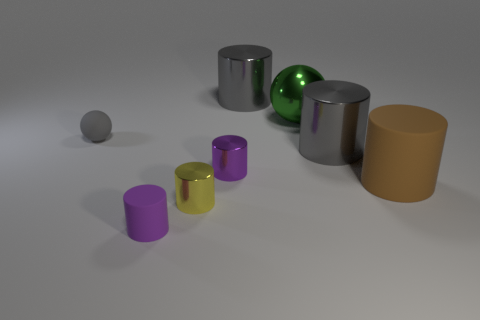Subtract 1 cylinders. How many cylinders are left? 5 Subtract all purple cylinders. How many cylinders are left? 4 Subtract all gray cylinders. How many cylinders are left? 4 Subtract all brown cylinders. Subtract all red blocks. How many cylinders are left? 5 Add 1 gray rubber objects. How many objects exist? 9 Subtract all cylinders. How many objects are left? 2 Subtract all small purple cylinders. Subtract all small cylinders. How many objects are left? 3 Add 6 large gray cylinders. How many large gray cylinders are left? 8 Add 5 large brown objects. How many large brown objects exist? 6 Subtract 0 brown cubes. How many objects are left? 8 